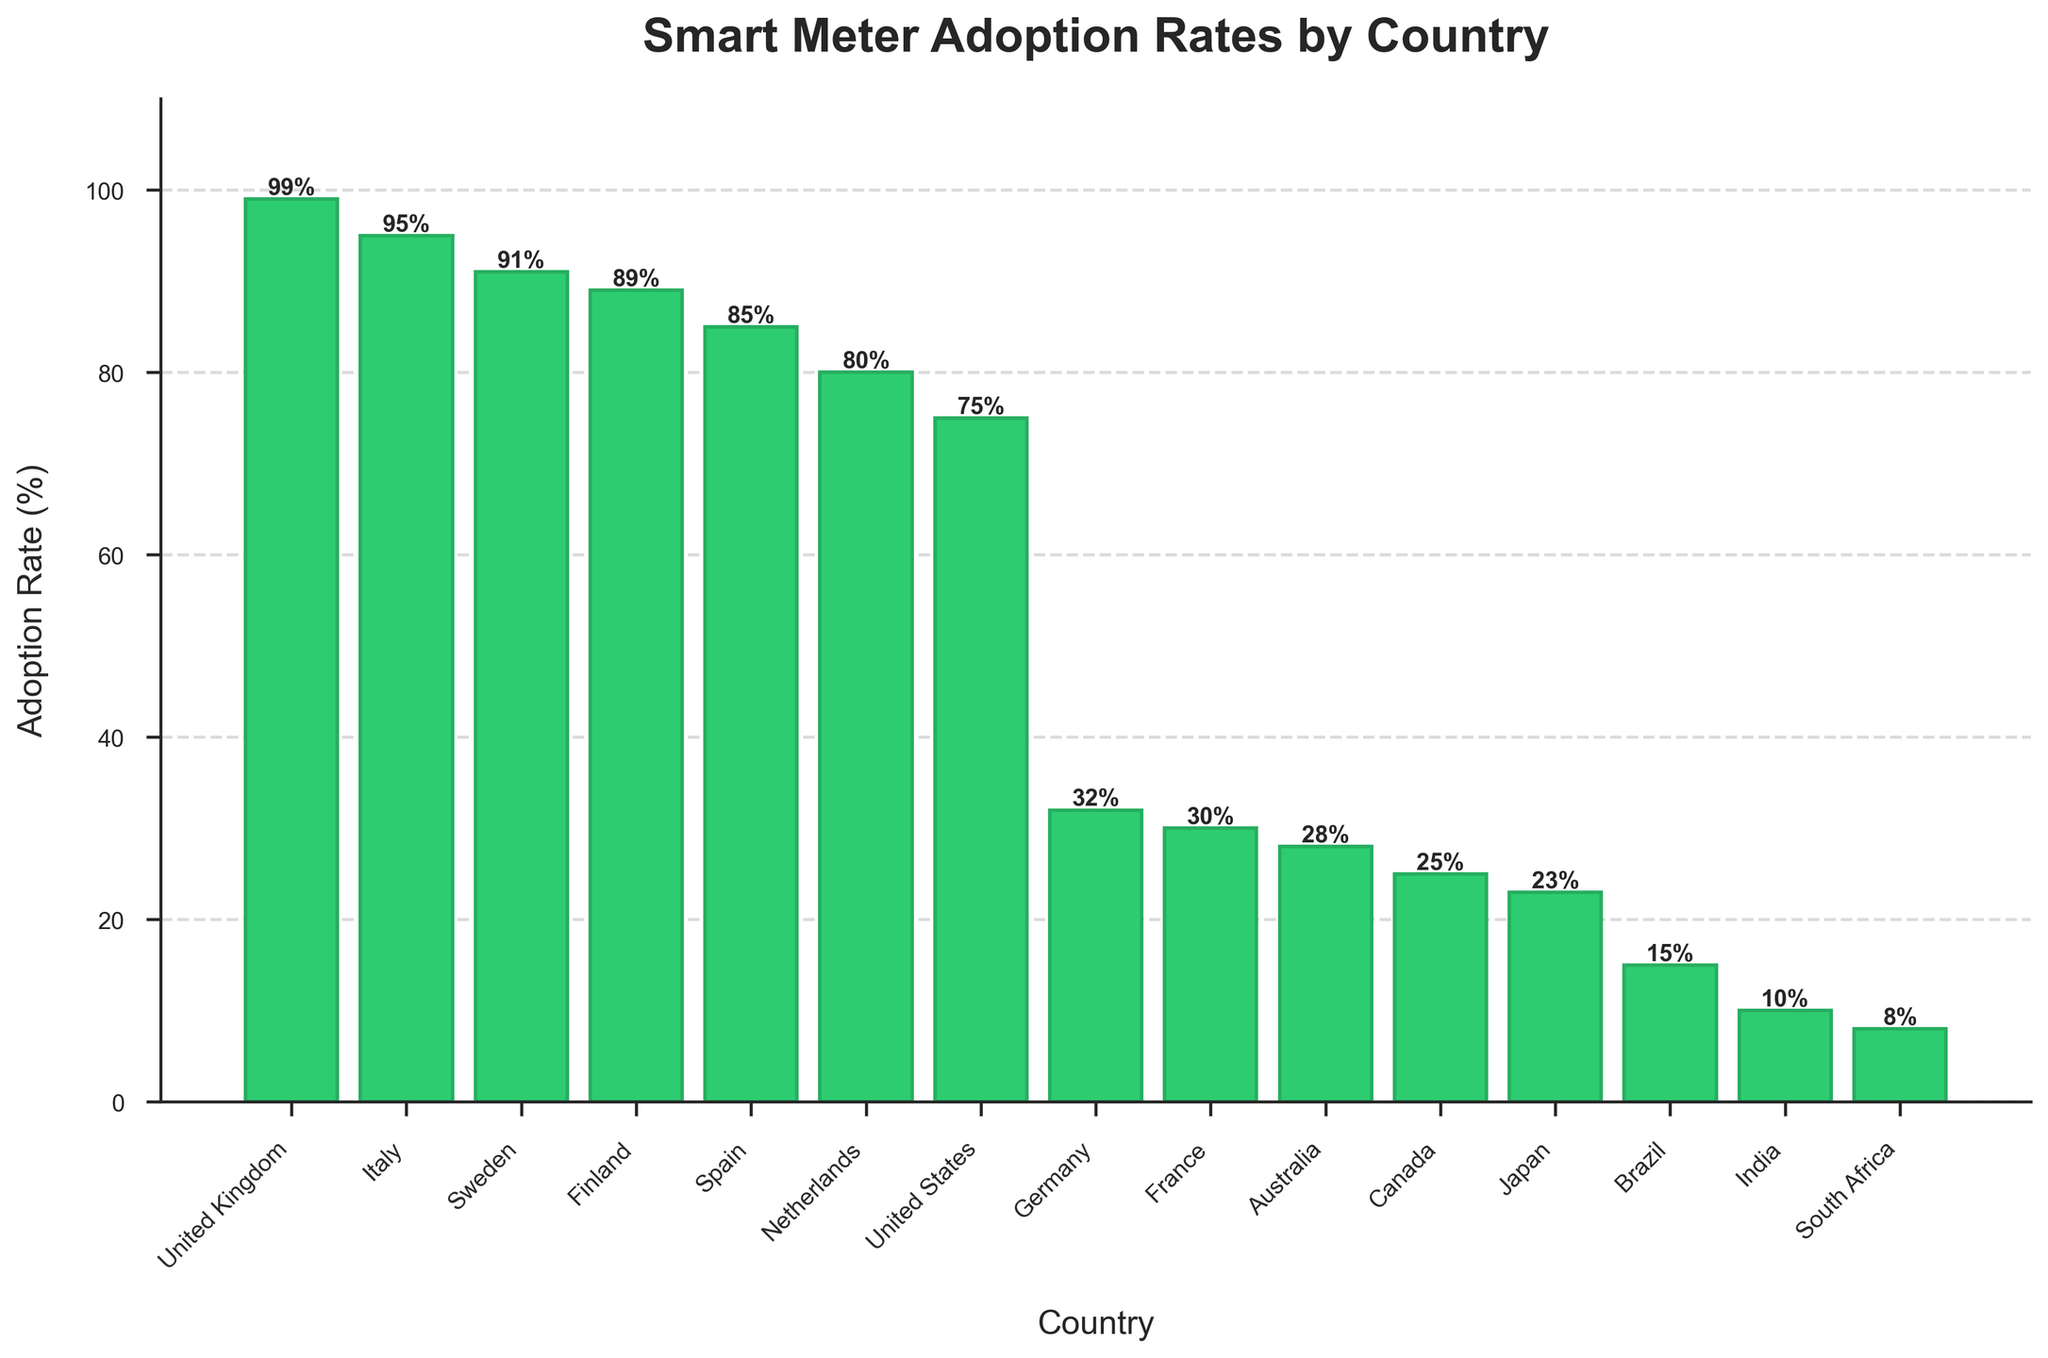Which country has the highest smart meter adoption rate? The highest bar visually is for the United Kingdom, which indicates the highest adoption rate.
Answer: United Kingdom Which country has a lower adoption rate, France or Germany? Comparing the heights of the two bars, France's bar is slightly shorter than Germany's.
Answer: France What's the difference in adoption rate between the United Kingdom and Japan? United Kingdom has a 99% adoption rate, while Japan has 23%. The difference is 99% - 23%.
Answer: 76% What is the sum of the adoption rates for the United States, Canada, and Brazil? The adoption rates are 75% (United States), 25% (Canada), and 15% (Brazil). The sum is 75 + 25 + 15.
Answer: 115% Which countries have adoption rates higher than 50%? Examining the bars visually, countries with bars extending above the 50% mark are the United Kingdom, Italy, Sweden, Finland, Spain, Netherlands, and the United States.
Answer: United Kingdom, Italy, Sweden, Finland, Spain, Netherlands, United States Which country has the smallest smart meter adoption rate? The smallest bar indicates that South Africa has the lowest adoption rate.
Answer: South Africa What's the average adoption rate of Italy, Sweden, and Finland? Adoption rates are 95% (Italy), 91% (Sweden), and 89% (Finland). The average is (95 + 91 + 89) / 3.
Answer: 91.67% What's the difference in adoption rates between Australia and South Africa? Australia's adoption rate is 28%, and South Africa's is 8%. The difference is 28% - 8%.
Answer: 20% Is the adoption rate in Brazil higher or lower than in India? The height of Brazil's bar is higher than India's bar, indicating a higher adoption rate.
Answer: Higher What's the median adoption rate for the countries displayed? To find the median, list the adoption rates in ascending order and find the middle value. The ordered rates are 8, 10, 15, 23, 25, 28, 30, 32, 75, 80, 85, 89, 91, 95, 99. The middle value (8th in the list) is 32%.
Answer: 32% 